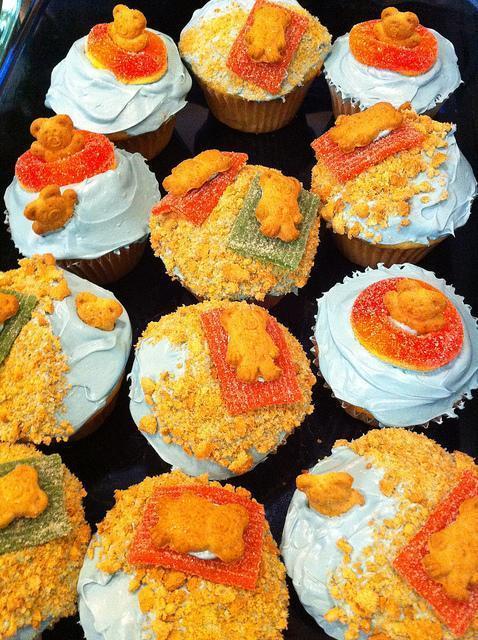How many cupcakes are in this scene?
Give a very brief answer. 12. How many cupcakes are there?
Give a very brief answer. 12. How many teddy bears are there?
Give a very brief answer. 5. How many cakes are there?
Give a very brief answer. 10. 